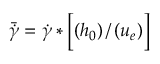<formula> <loc_0><loc_0><loc_500><loc_500>\ B a r { \ D o t { \gamma } } = \ D o t { \gamma } * \left [ \left ( h _ { 0 } \right ) / \left ( u _ { e } \right ) \right ]</formula> 